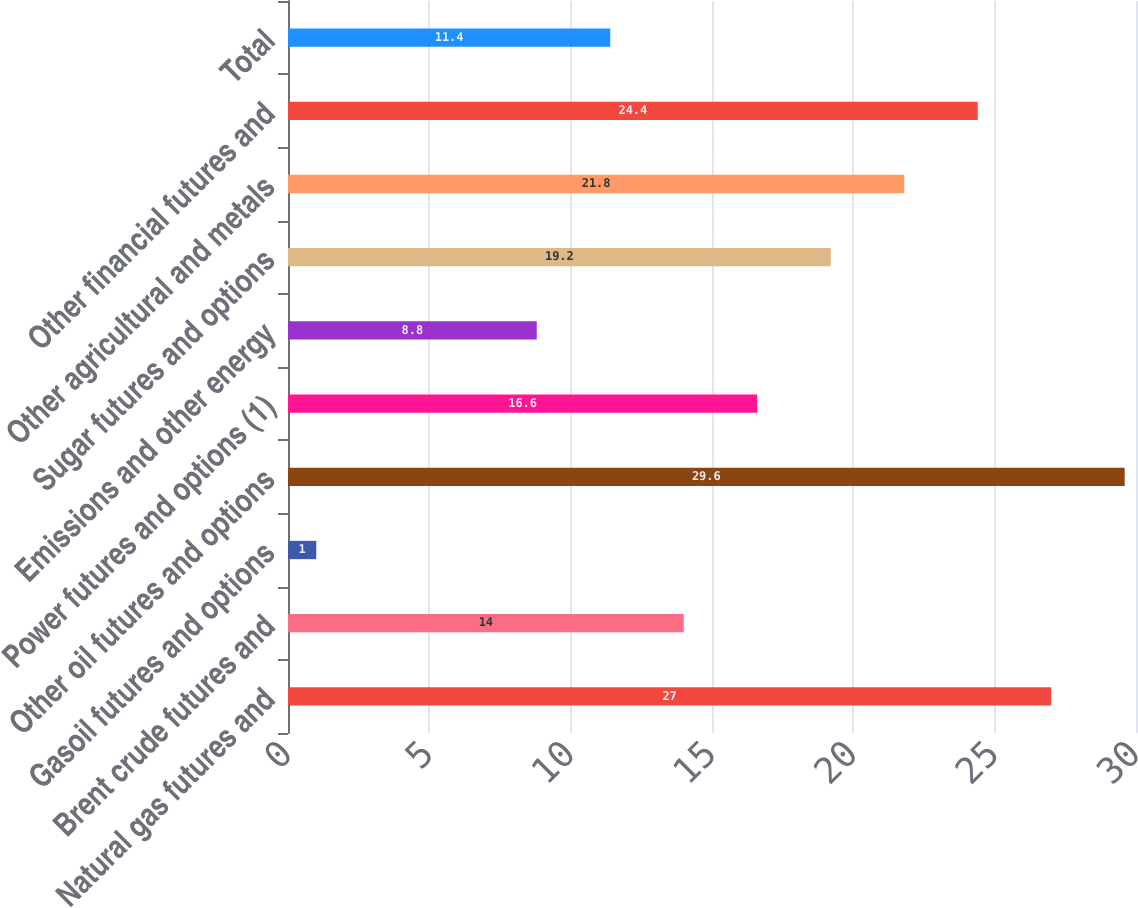Convert chart to OTSL. <chart><loc_0><loc_0><loc_500><loc_500><bar_chart><fcel>Natural gas futures and<fcel>Brent crude futures and<fcel>Gasoil futures and options<fcel>Other oil futures and options<fcel>Power futures and options (1)<fcel>Emissions and other energy<fcel>Sugar futures and options<fcel>Other agricultural and metals<fcel>Other financial futures and<fcel>Total<nl><fcel>27<fcel>14<fcel>1<fcel>29.6<fcel>16.6<fcel>8.8<fcel>19.2<fcel>21.8<fcel>24.4<fcel>11.4<nl></chart> 